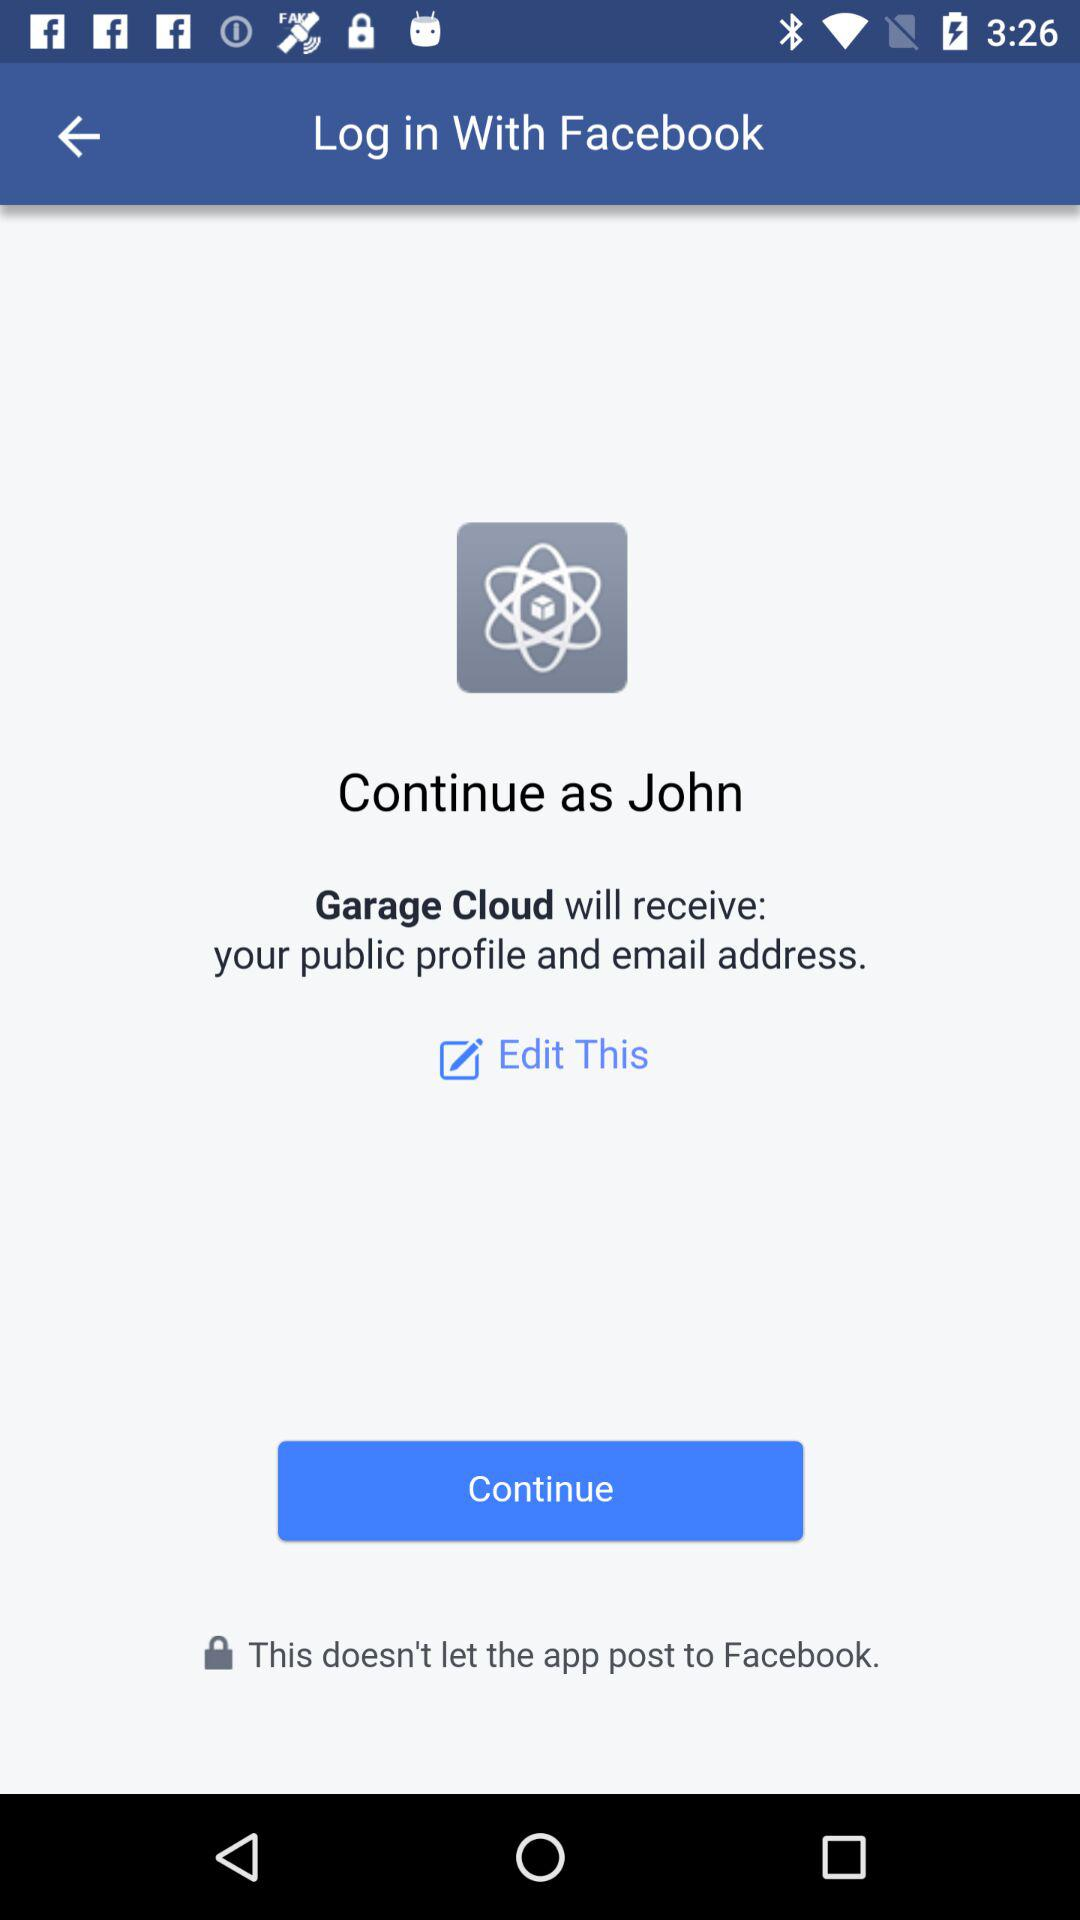What is the user name? The user name is John. 